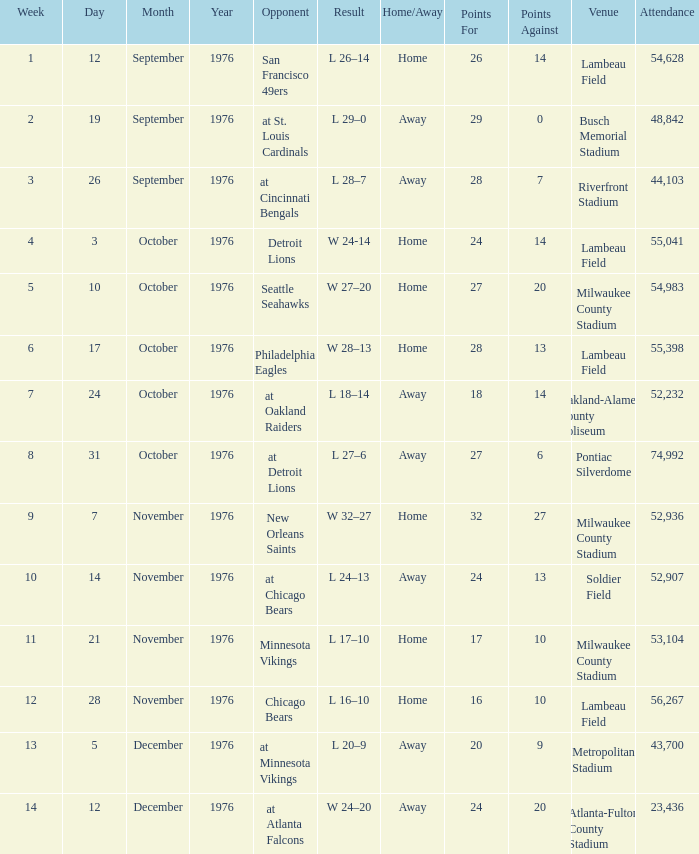What is the mean attendance for the match on september 26, 1976? 44103.0. 